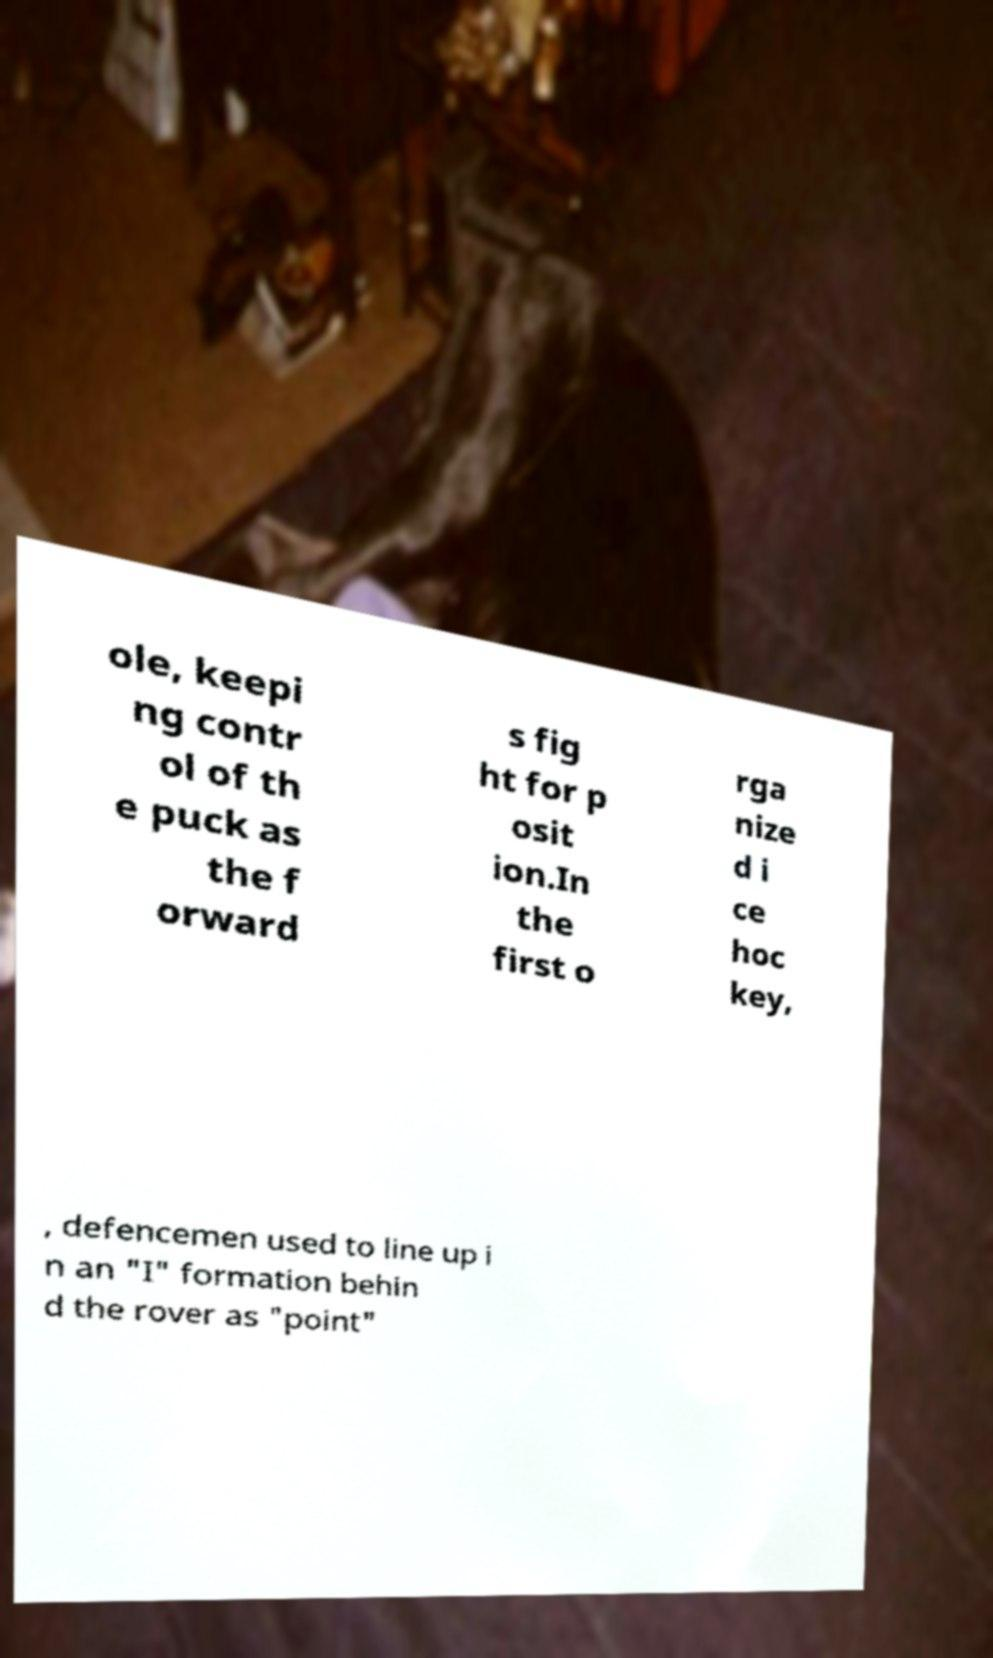Can you accurately transcribe the text from the provided image for me? ole, keepi ng contr ol of th e puck as the f orward s fig ht for p osit ion.In the first o rga nize d i ce hoc key, , defencemen used to line up i n an "I" formation behin d the rover as "point" 